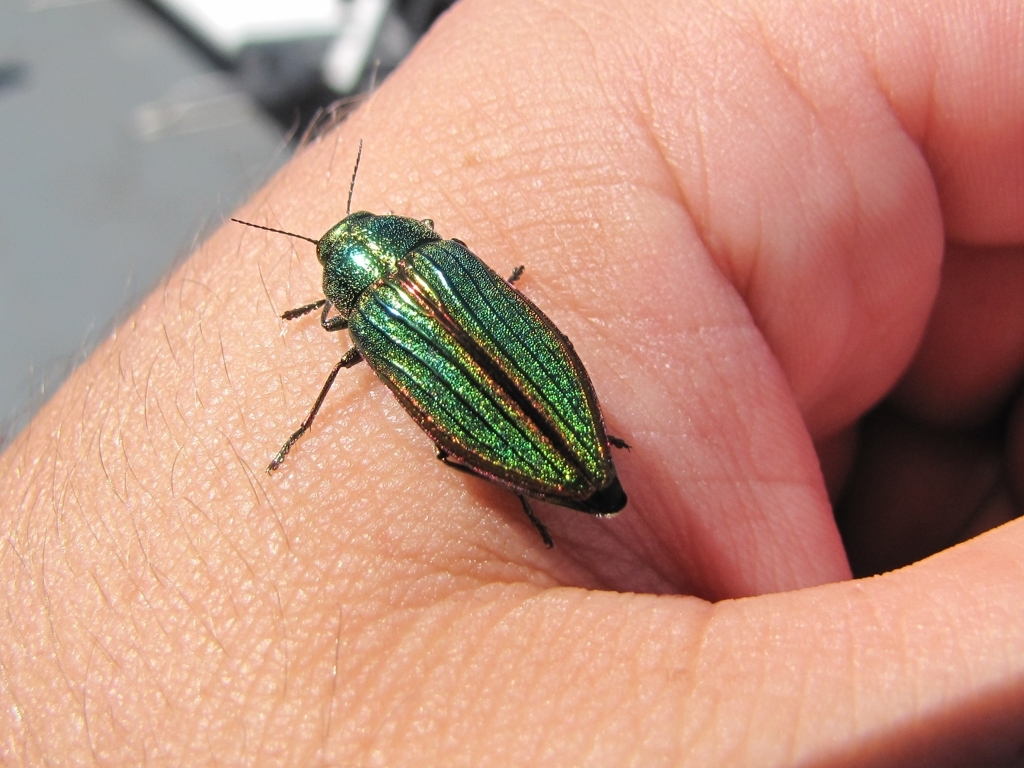Can you tell me how the insect's color might change in different lighting conditions? Certainly, the insect's color is due to structural coloration which can change dramatically with viewing angle and light intensity. In direct sunlight, the colors would be most vivid, but in diffused or dimmer lights, the colors may appear less intense, and the shine might be subdued, blending more with the surroundings. 